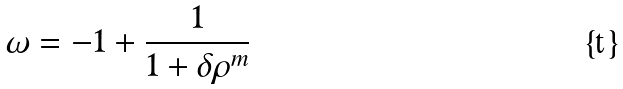Convert formula to latex. <formula><loc_0><loc_0><loc_500><loc_500>\omega = - 1 + \frac { 1 } { 1 + \delta { \rho } ^ { m } }</formula> 